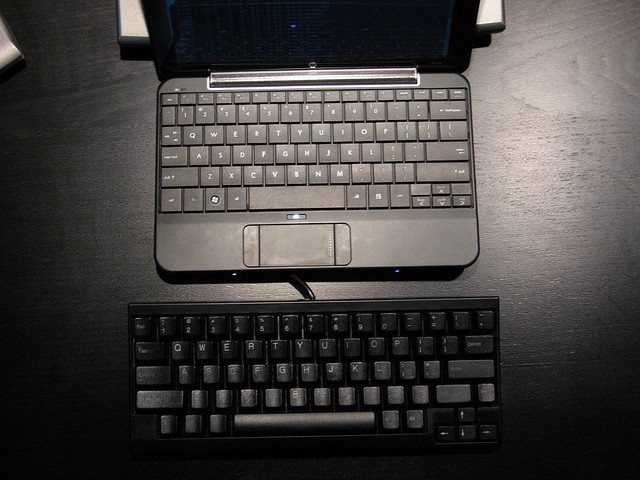Describe the objects in this image and their specific colors. I can see laptop in black, darkgray, and gray tones, keyboard in black and gray tones, and keyboard in black, darkgray, and gray tones in this image. 